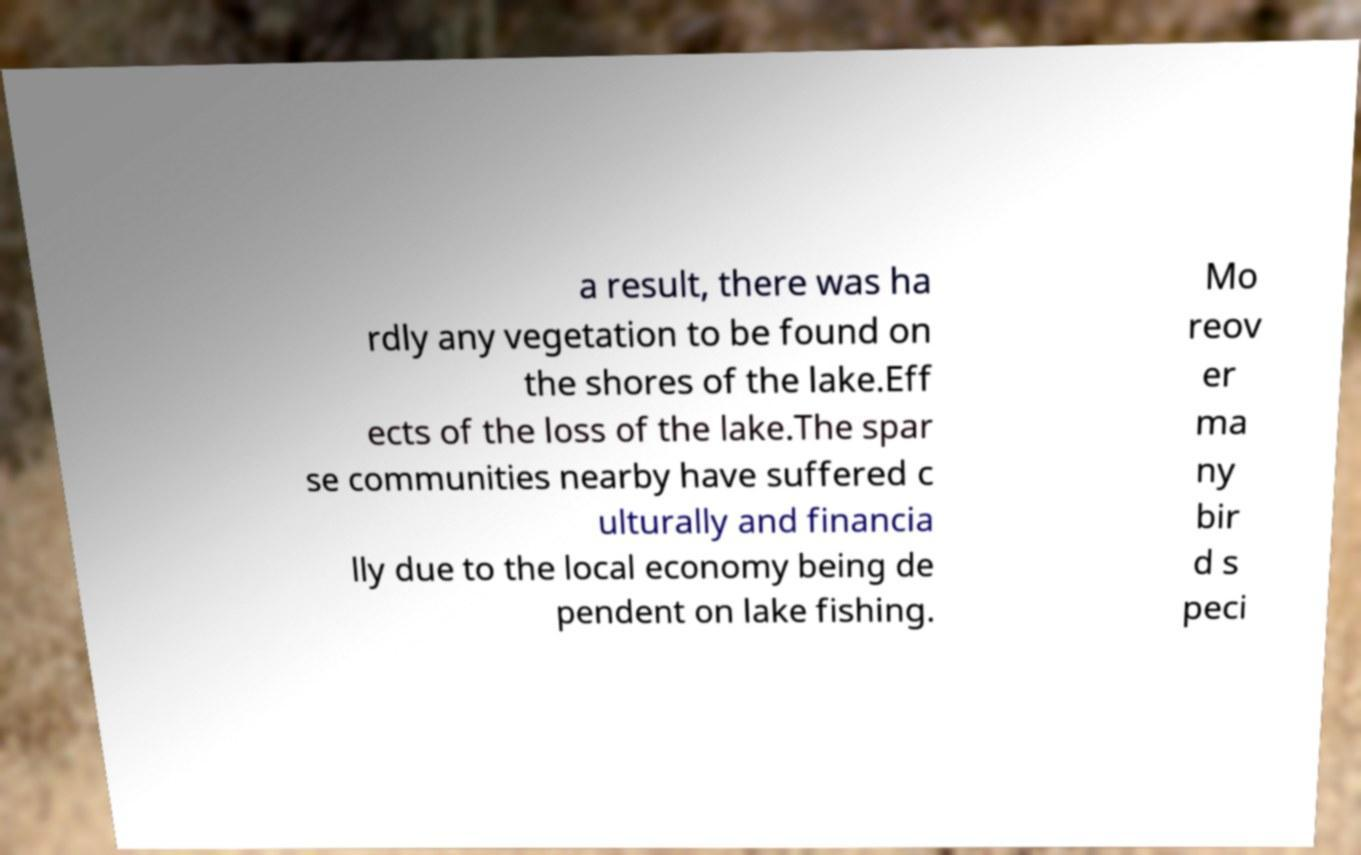I need the written content from this picture converted into text. Can you do that? a result, there was ha rdly any vegetation to be found on the shores of the lake.Eff ects of the loss of the lake.The spar se communities nearby have suffered c ulturally and financia lly due to the local economy being de pendent on lake fishing. Mo reov er ma ny bir d s peci 